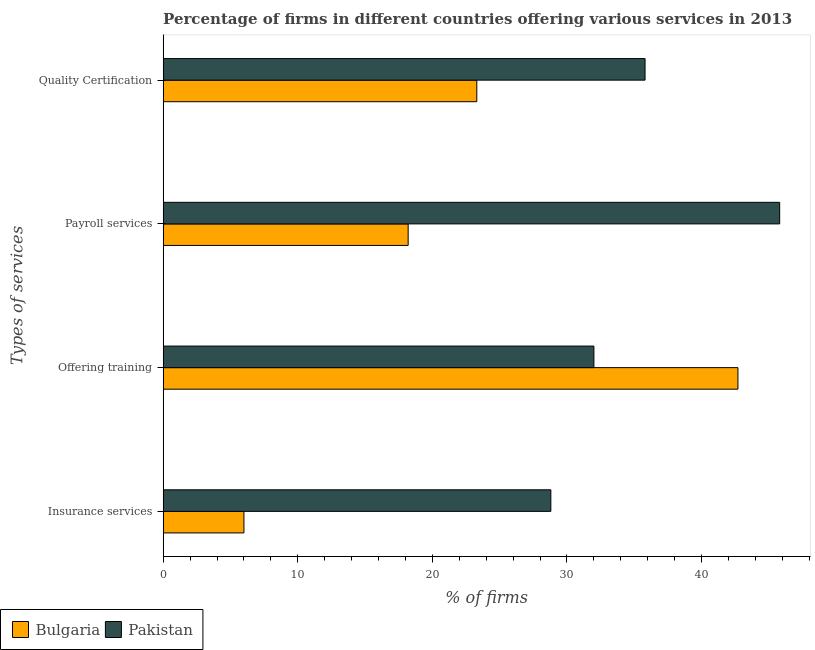How many different coloured bars are there?
Offer a terse response. 2. How many groups of bars are there?
Your response must be concise. 4. Are the number of bars per tick equal to the number of legend labels?
Keep it short and to the point. Yes. Are the number of bars on each tick of the Y-axis equal?
Provide a succinct answer. Yes. How many bars are there on the 3rd tick from the top?
Provide a succinct answer. 2. What is the label of the 1st group of bars from the top?
Provide a succinct answer. Quality Certification. Across all countries, what is the maximum percentage of firms offering training?
Provide a succinct answer. 42.7. What is the total percentage of firms offering payroll services in the graph?
Make the answer very short. 64. What is the difference between the percentage of firms offering quality certification in Bulgaria and that in Pakistan?
Keep it short and to the point. -12.5. What is the average percentage of firms offering training per country?
Your response must be concise. 37.35. What is the difference between the percentage of firms offering training and percentage of firms offering payroll services in Bulgaria?
Your answer should be compact. 24.5. What is the ratio of the percentage of firms offering quality certification in Bulgaria to that in Pakistan?
Give a very brief answer. 0.65. Is the percentage of firms offering quality certification in Bulgaria less than that in Pakistan?
Your response must be concise. Yes. Is the difference between the percentage of firms offering payroll services in Pakistan and Bulgaria greater than the difference between the percentage of firms offering insurance services in Pakistan and Bulgaria?
Offer a terse response. Yes. What is the difference between the highest and the second highest percentage of firms offering payroll services?
Offer a very short reply. 27.6. What is the difference between the highest and the lowest percentage of firms offering payroll services?
Your answer should be very brief. 27.6. In how many countries, is the percentage of firms offering quality certification greater than the average percentage of firms offering quality certification taken over all countries?
Keep it short and to the point. 1. What is the difference between two consecutive major ticks on the X-axis?
Provide a short and direct response. 10. Does the graph contain grids?
Offer a very short reply. No. Where does the legend appear in the graph?
Your answer should be very brief. Bottom left. How many legend labels are there?
Ensure brevity in your answer.  2. How are the legend labels stacked?
Give a very brief answer. Horizontal. What is the title of the graph?
Offer a very short reply. Percentage of firms in different countries offering various services in 2013. What is the label or title of the X-axis?
Ensure brevity in your answer.  % of firms. What is the label or title of the Y-axis?
Provide a succinct answer. Types of services. What is the % of firms in Pakistan in Insurance services?
Ensure brevity in your answer.  28.8. What is the % of firms of Bulgaria in Offering training?
Offer a very short reply. 42.7. What is the % of firms in Bulgaria in Payroll services?
Your response must be concise. 18.2. What is the % of firms in Pakistan in Payroll services?
Keep it short and to the point. 45.8. What is the % of firms of Bulgaria in Quality Certification?
Offer a very short reply. 23.3. What is the % of firms of Pakistan in Quality Certification?
Keep it short and to the point. 35.8. Across all Types of services, what is the maximum % of firms of Bulgaria?
Provide a succinct answer. 42.7. Across all Types of services, what is the maximum % of firms in Pakistan?
Your answer should be very brief. 45.8. Across all Types of services, what is the minimum % of firms in Bulgaria?
Your answer should be very brief. 6. Across all Types of services, what is the minimum % of firms in Pakistan?
Your answer should be compact. 28.8. What is the total % of firms in Bulgaria in the graph?
Ensure brevity in your answer.  90.2. What is the total % of firms in Pakistan in the graph?
Your answer should be very brief. 142.4. What is the difference between the % of firms in Bulgaria in Insurance services and that in Offering training?
Offer a very short reply. -36.7. What is the difference between the % of firms of Pakistan in Insurance services and that in Offering training?
Your answer should be very brief. -3.2. What is the difference between the % of firms of Bulgaria in Insurance services and that in Quality Certification?
Keep it short and to the point. -17.3. What is the difference between the % of firms in Pakistan in Offering training and that in Payroll services?
Ensure brevity in your answer.  -13.8. What is the difference between the % of firms of Pakistan in Payroll services and that in Quality Certification?
Make the answer very short. 10. What is the difference between the % of firms of Bulgaria in Insurance services and the % of firms of Pakistan in Offering training?
Your answer should be compact. -26. What is the difference between the % of firms of Bulgaria in Insurance services and the % of firms of Pakistan in Payroll services?
Offer a very short reply. -39.8. What is the difference between the % of firms of Bulgaria in Insurance services and the % of firms of Pakistan in Quality Certification?
Your answer should be compact. -29.8. What is the difference between the % of firms of Bulgaria in Offering training and the % of firms of Pakistan in Payroll services?
Keep it short and to the point. -3.1. What is the difference between the % of firms of Bulgaria in Offering training and the % of firms of Pakistan in Quality Certification?
Make the answer very short. 6.9. What is the difference between the % of firms of Bulgaria in Payroll services and the % of firms of Pakistan in Quality Certification?
Your answer should be compact. -17.6. What is the average % of firms in Bulgaria per Types of services?
Your answer should be very brief. 22.55. What is the average % of firms in Pakistan per Types of services?
Your response must be concise. 35.6. What is the difference between the % of firms in Bulgaria and % of firms in Pakistan in Insurance services?
Your response must be concise. -22.8. What is the difference between the % of firms in Bulgaria and % of firms in Pakistan in Payroll services?
Ensure brevity in your answer.  -27.6. What is the ratio of the % of firms of Bulgaria in Insurance services to that in Offering training?
Keep it short and to the point. 0.14. What is the ratio of the % of firms of Pakistan in Insurance services to that in Offering training?
Your answer should be very brief. 0.9. What is the ratio of the % of firms of Bulgaria in Insurance services to that in Payroll services?
Your response must be concise. 0.33. What is the ratio of the % of firms of Pakistan in Insurance services to that in Payroll services?
Make the answer very short. 0.63. What is the ratio of the % of firms in Bulgaria in Insurance services to that in Quality Certification?
Offer a terse response. 0.26. What is the ratio of the % of firms of Pakistan in Insurance services to that in Quality Certification?
Give a very brief answer. 0.8. What is the ratio of the % of firms of Bulgaria in Offering training to that in Payroll services?
Give a very brief answer. 2.35. What is the ratio of the % of firms in Pakistan in Offering training to that in Payroll services?
Offer a terse response. 0.7. What is the ratio of the % of firms in Bulgaria in Offering training to that in Quality Certification?
Your response must be concise. 1.83. What is the ratio of the % of firms in Pakistan in Offering training to that in Quality Certification?
Give a very brief answer. 0.89. What is the ratio of the % of firms in Bulgaria in Payroll services to that in Quality Certification?
Make the answer very short. 0.78. What is the ratio of the % of firms in Pakistan in Payroll services to that in Quality Certification?
Your response must be concise. 1.28. What is the difference between the highest and the second highest % of firms in Pakistan?
Your answer should be very brief. 10. What is the difference between the highest and the lowest % of firms in Bulgaria?
Keep it short and to the point. 36.7. 